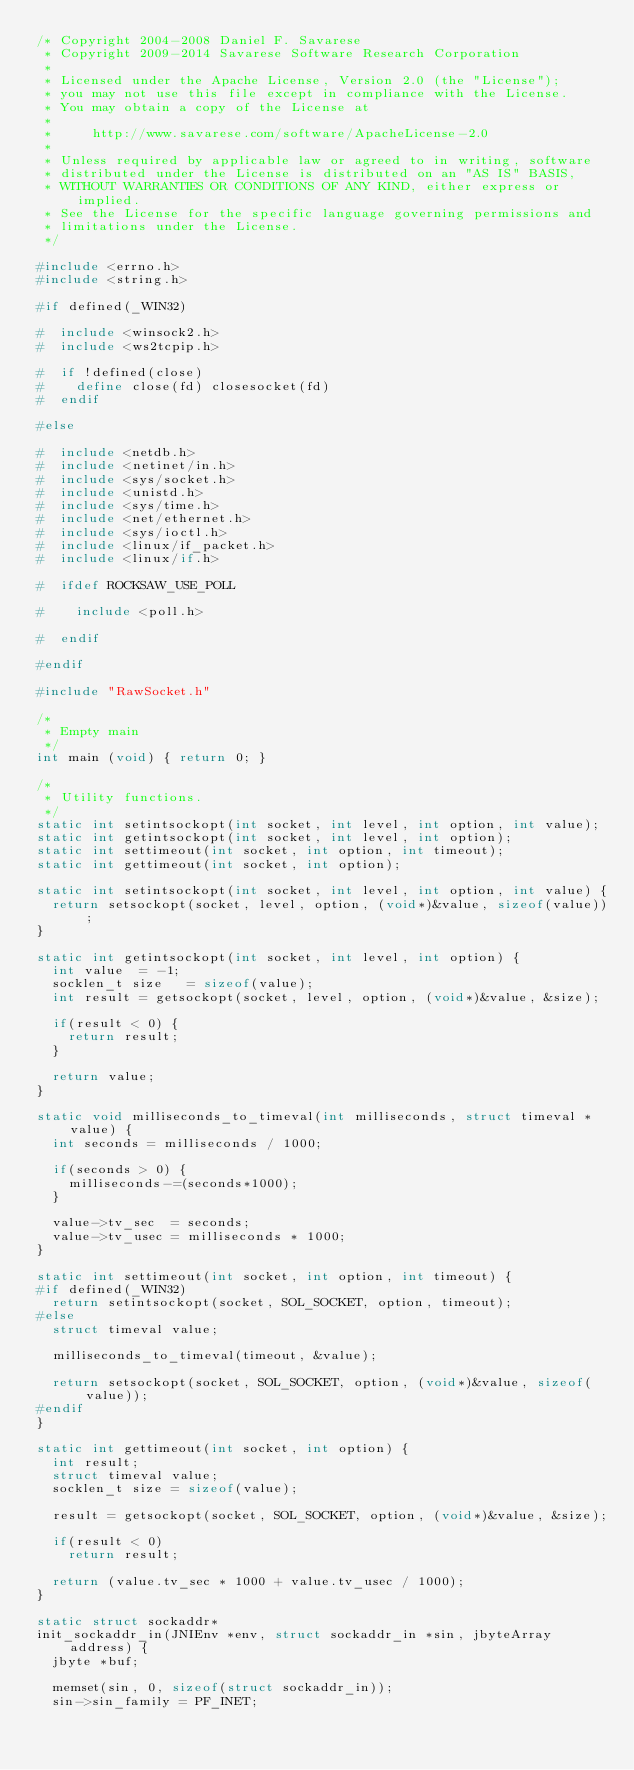Convert code to text. <code><loc_0><loc_0><loc_500><loc_500><_C_>/* Copyright 2004-2008 Daniel F. Savarese
 * Copyright 2009-2014 Savarese Software Research Corporation
 *
 * Licensed under the Apache License, Version 2.0 (the "License");
 * you may not use this file except in compliance with the License.
 * You may obtain a copy of the License at
 *
 *     http://www.savarese.com/software/ApacheLicense-2.0
 *
 * Unless required by applicable law or agreed to in writing, software
 * distributed under the License is distributed on an "AS IS" BASIS,
 * WITHOUT WARRANTIES OR CONDITIONS OF ANY KIND, either express or implied.
 * See the License for the specific language governing permissions and
 * limitations under the License.
 */

#include <errno.h>
#include <string.h>

#if defined(_WIN32)

#  include <winsock2.h>
#  include <ws2tcpip.h>

#  if !defined(close)
#    define close(fd) closesocket(fd)
#  endif

#else

#  include <netdb.h>
#  include <netinet/in.h>
#  include <sys/socket.h>
#  include <unistd.h>
#  include <sys/time.h>
#  include <net/ethernet.h>
#  include <sys/ioctl.h>
#  include <linux/if_packet.h>
#  include <linux/if.h>

#  ifdef ROCKSAW_USE_POLL

#    include <poll.h>

#  endif

#endif

#include "RawSocket.h"

/*
 * Empty main
 */
int main (void) { return 0; }

/*
 * Utility functions.
 */
static int setintsockopt(int socket, int level, int option, int value);
static int getintsockopt(int socket, int level, int option);
static int settimeout(int socket, int option, int timeout);
static int gettimeout(int socket, int option);

static int setintsockopt(int socket, int level, int option, int value) {
  return setsockopt(socket, level, option, (void*)&value, sizeof(value));
}

static int getintsockopt(int socket, int level, int option) {
  int value  = -1;
  socklen_t size   = sizeof(value);
  int result = getsockopt(socket, level, option, (void*)&value, &size);

  if(result < 0) {
    return result;
  }

  return value;
}

static void milliseconds_to_timeval(int milliseconds, struct timeval *value) {
  int seconds = milliseconds / 1000;

  if(seconds > 0) {
    milliseconds-=(seconds*1000);
  }

  value->tv_sec  = seconds;
  value->tv_usec = milliseconds * 1000;
}

static int settimeout(int socket, int option, int timeout) {
#if defined(_WIN32)
  return setintsockopt(socket, SOL_SOCKET, option, timeout);
#else
  struct timeval value;

  milliseconds_to_timeval(timeout, &value);

  return setsockopt(socket, SOL_SOCKET, option, (void*)&value, sizeof(value));
#endif
}

static int gettimeout(int socket, int option) {
  int result;
  struct timeval value;
  socklen_t size = sizeof(value);

  result = getsockopt(socket, SOL_SOCKET, option, (void*)&value, &size);

  if(result < 0)
    return result;

  return (value.tv_sec * 1000 + value.tv_usec / 1000);
}

static struct sockaddr*
init_sockaddr_in(JNIEnv *env, struct sockaddr_in *sin, jbyteArray address) {
  jbyte *buf;

  memset(sin, 0, sizeof(struct sockaddr_in));
  sin->sin_family = PF_INET;</code> 